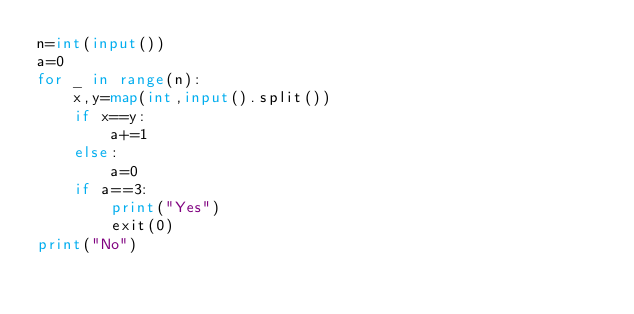<code> <loc_0><loc_0><loc_500><loc_500><_Python_>n=int(input())
a=0
for _ in range(n):
    x,y=map(int,input().split())
    if x==y:
        a+=1
    else:
        a=0
    if a==3:
        print("Yes")
        exit(0)
print("No")
</code> 